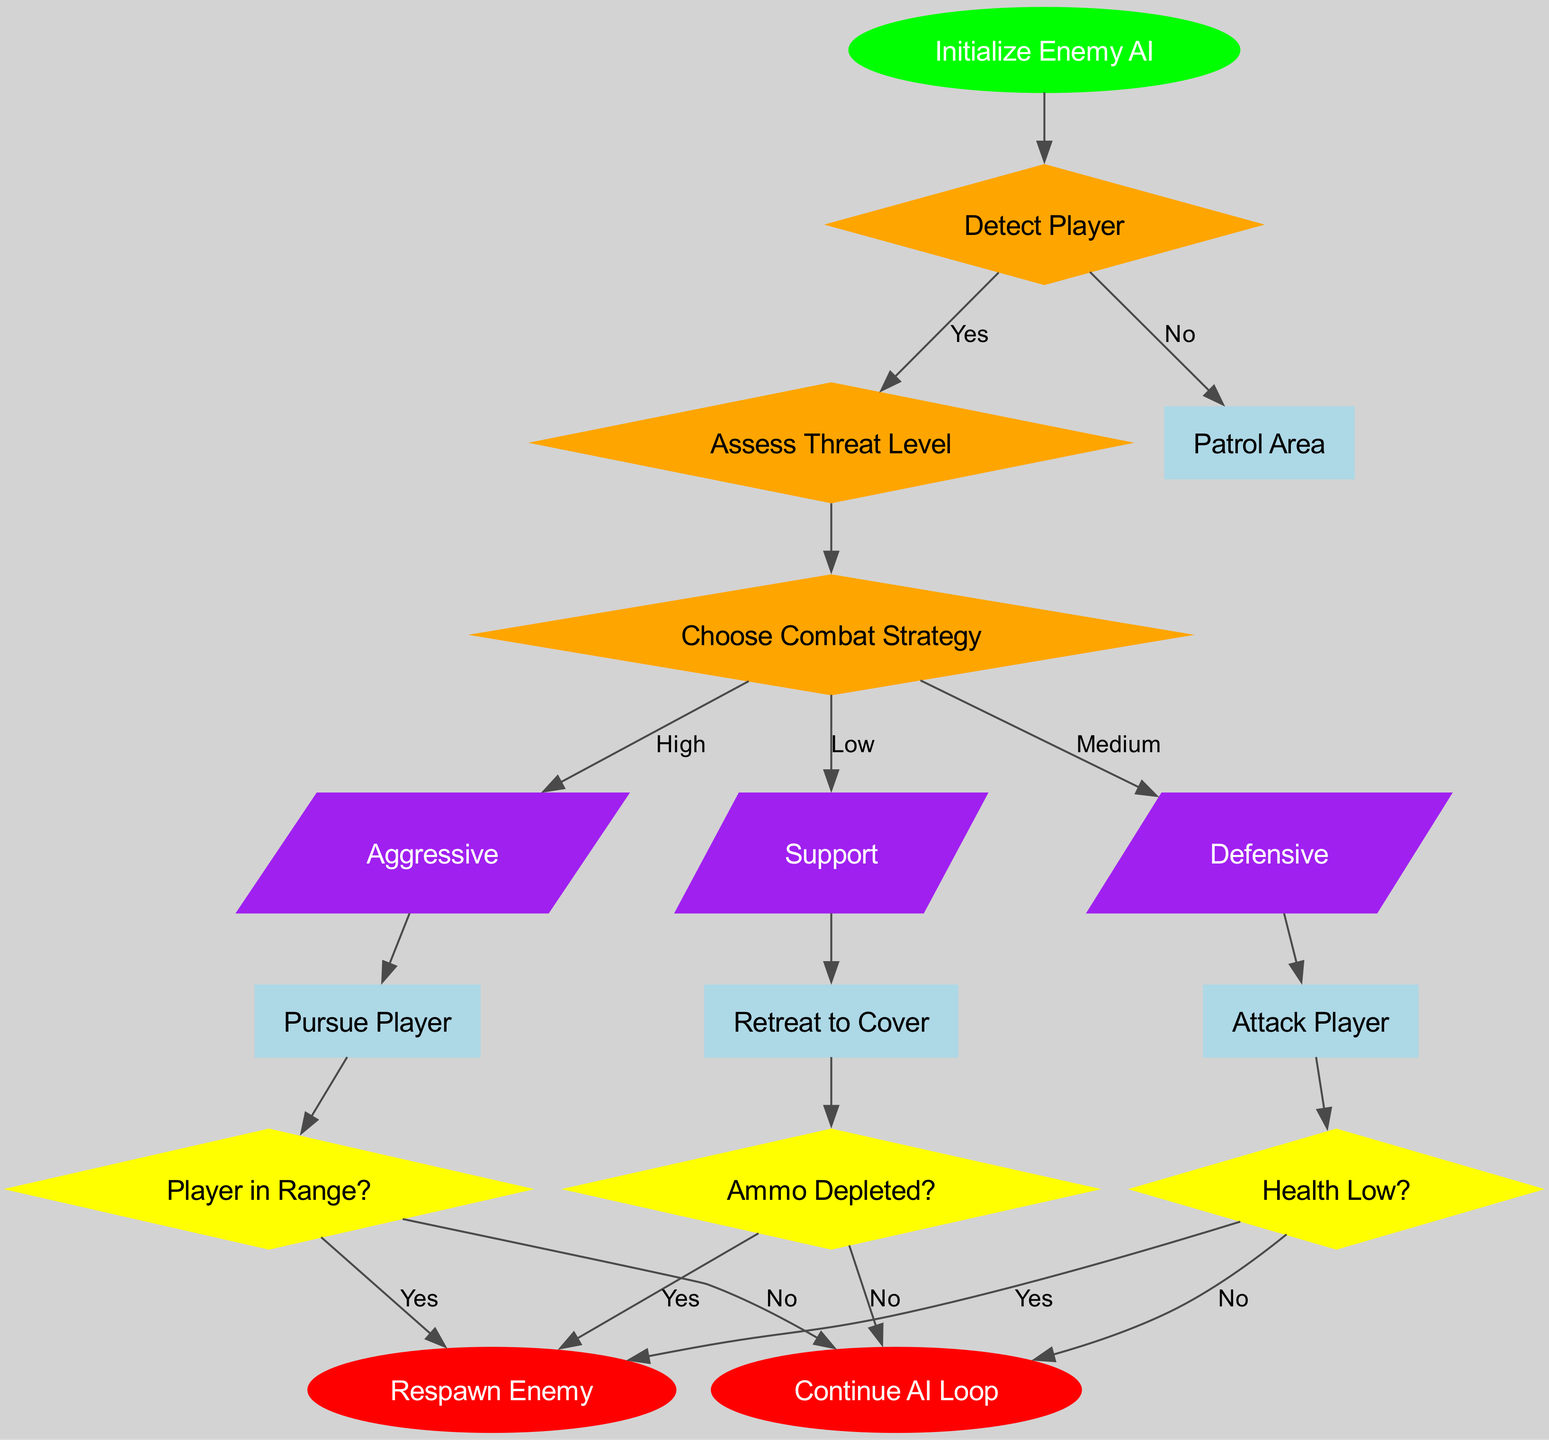What is the first action the Enemy AI takes if the player is not detected? The flowchart indicates that if the player is not detected, the Enemy AI will begin patrolling the area as the first action. This is shown by the edge leading from the detection decision node when the answer is 'No' to the patrol action.
Answer: Patrol Area How many decision nodes are present in the diagram? The diagram lists three decision nodes: Detect Player, Assess Threat Level, and Choose Combat Strategy. By visually counting the diamond-shaped nodes labeled, we arrive at the number three.
Answer: 3 What happens when the health of the enemy AI is low? When the health is low, the AI will typically retreat to cover, as indicated by the edge leading from the health condition decision node when the answer is 'Yes’. This represents a strategic choice for survival in the flowchart.
Answer: Retreat to Cover If the enemy AI detects the player, what is the next node it goes to? Upon detecting the player, the flowchart shows that the next step leads to assessing the threat level. This follows the path from the first decision node labeled 'Detect Player' to the next node, indicating a subsequent action.
Answer: Assess Threat Level What color are the action nodes in the diagram? The action nodes are colored light blue as indicated by the diagram settings established for those rectangles. This color choice visually differentiates actions from decision and condition nodes.
Answer: Light Blue What is the outcome if the enemy AI's ammo is depleted? If the enemy AI's ammo is depleted, the flowchart shows that it will likely retreat to cover, as indicated by the edge from the ammo condition decision node leading to that specific action when the answer is 'Yes'.
Answer: Retreat to Cover What strategy does the enemy AI pursue when the threat level is assessed as high? According to the flowchart, when the threat level is assessed as high, the AI chooses an aggressive strategy, which points to applying more direct and confrontational tactics in combat.
Answer: Aggressive How many total end nodes does the diagram have? The diagram contains two end nodes, which are labeled 'Continue AI Loop' and 'Respawn Enemy'. Counting these nodes demonstrates that there are two finish points in the flowchart ending branch.
Answer: 2 What type of node is used for the strategy options in the diagram? The strategy options in the diagram are represented using parallelogram-shaped nodes, which are distinctly colored purple to differentiate them from other types of nodes in the flowchart.
Answer: Parallelogram 